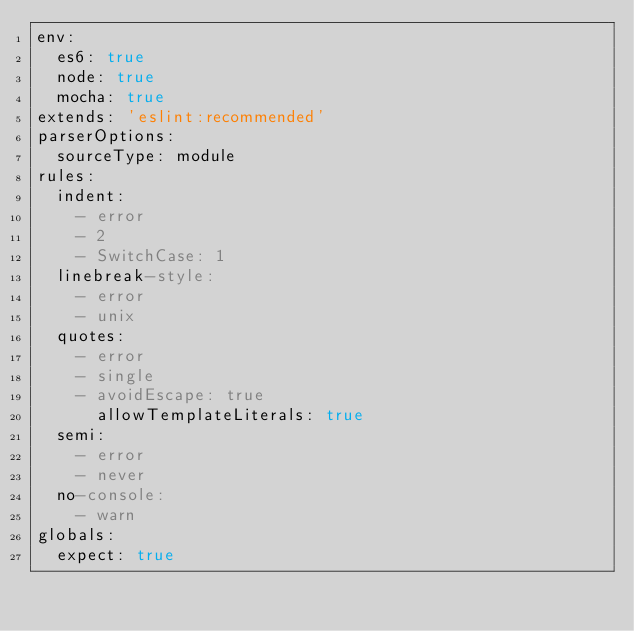<code> <loc_0><loc_0><loc_500><loc_500><_YAML_>env:
  es6: true
  node: true
  mocha: true
extends: 'eslint:recommended'
parserOptions:
  sourceType: module
rules:
  indent:
    - error
    - 2
    - SwitchCase: 1
  linebreak-style:
    - error
    - unix
  quotes:
    - error
    - single
    - avoidEscape: true
      allowTemplateLiterals: true
  semi:
    - error
    - never
  no-console:
    - warn
globals:
  expect: true
</code> 